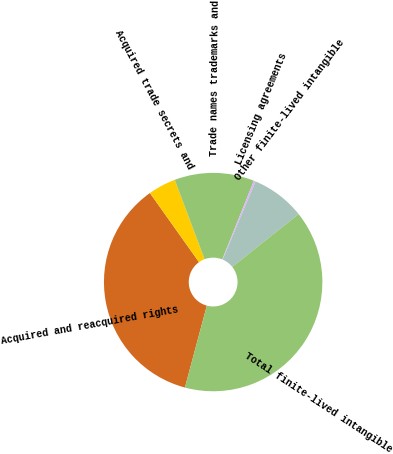<chart> <loc_0><loc_0><loc_500><loc_500><pie_chart><fcel>Acquired and reacquired rights<fcel>Acquired trade secrets and<fcel>Trade names trademarks and<fcel>Licensing agreements<fcel>Other finite-lived intangible<fcel>Total finite-lived intangible<nl><fcel>36.01%<fcel>4.11%<fcel>11.8%<fcel>0.27%<fcel>7.96%<fcel>39.85%<nl></chart> 